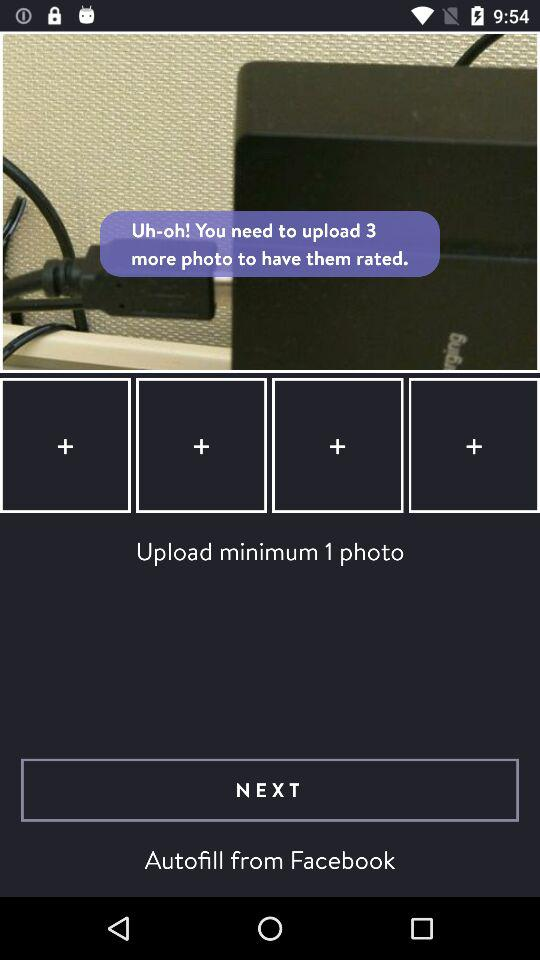How many more photos do I need to upload to have them rated?
Answer the question using a single word or phrase. 3 